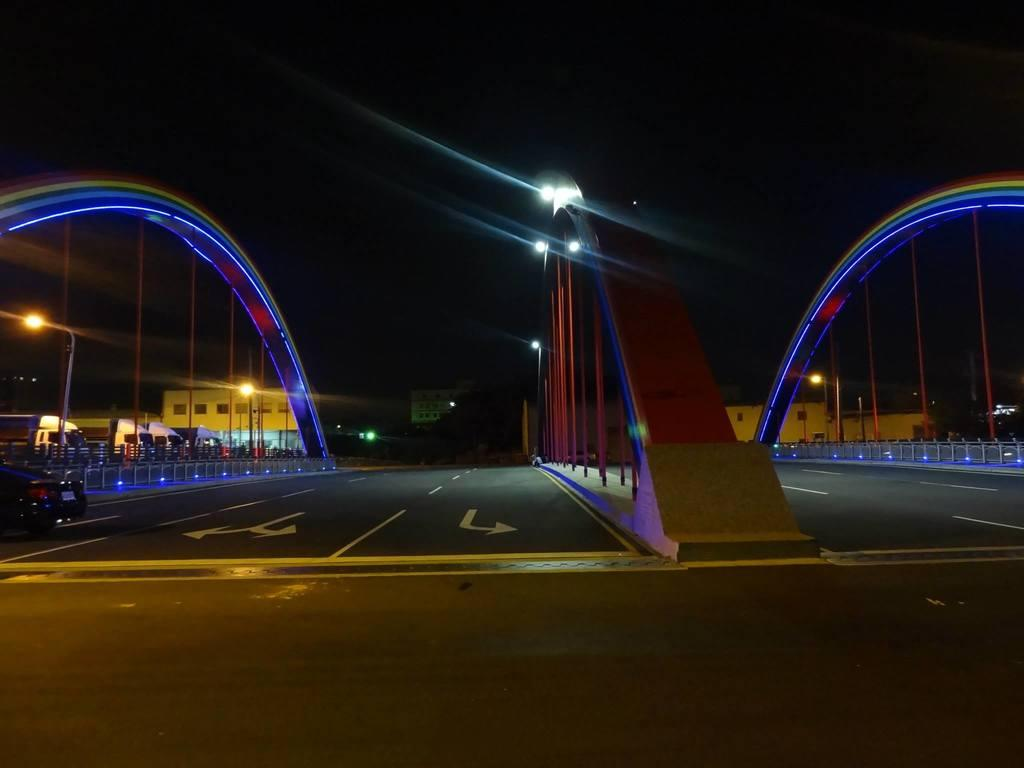What architectural features can be seen in the image? There are arches in the image. What type of illumination is present in the image? There are lights in the image. What structures support the lights and arches? There are poles in the image. What safety features are present in the image? There are railings in the image. What type of infrastructure is visible in the image? There are roads and vehicles in the image. What can be seen in the background of the image? The background of the image includes buildings, trees, and lights. How would you describe the overall lighting in the image? The background has a dark view, but there are lights present. Where are the cows located in the image? There are no cows present in the image. What type of fan can be seen in the image? There is no fan present in the image. 